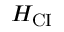<formula> <loc_0><loc_0><loc_500><loc_500>H _ { C I }</formula> 